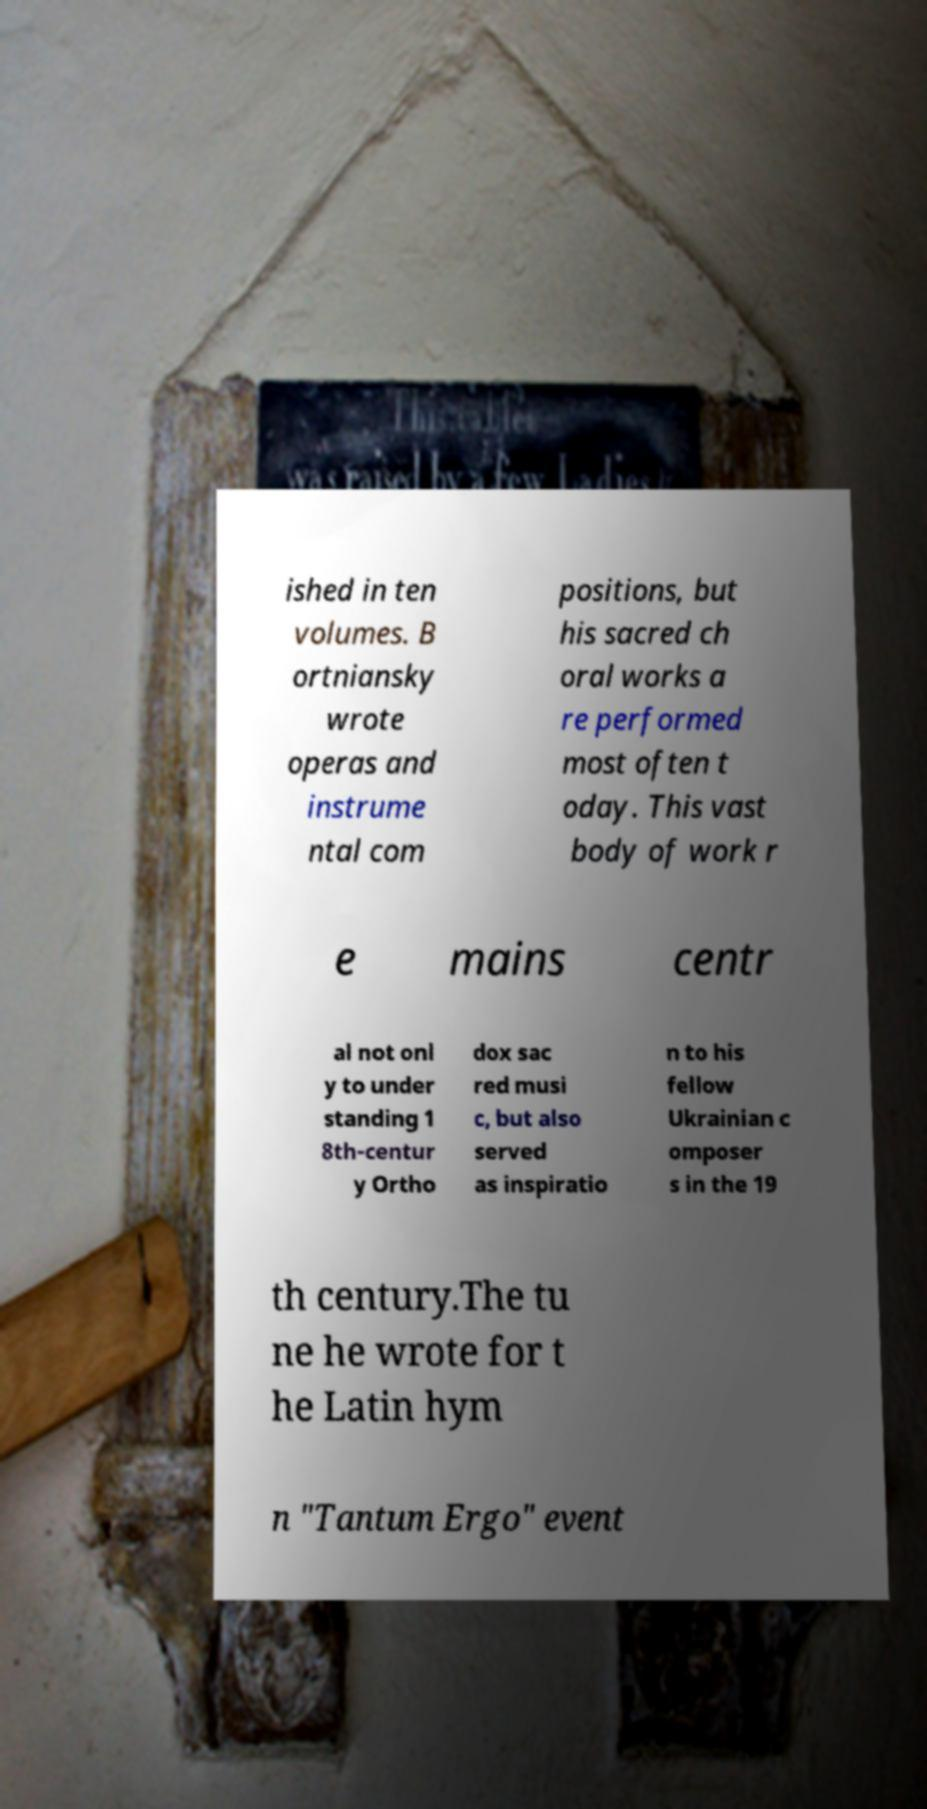What messages or text are displayed in this image? I need them in a readable, typed format. ished in ten volumes. B ortniansky wrote operas and instrume ntal com positions, but his sacred ch oral works a re performed most often t oday. This vast body of work r e mains centr al not onl y to under standing 1 8th-centur y Ortho dox sac red musi c, but also served as inspiratio n to his fellow Ukrainian c omposer s in the 19 th century.The tu ne he wrote for t he Latin hym n "Tantum Ergo" event 